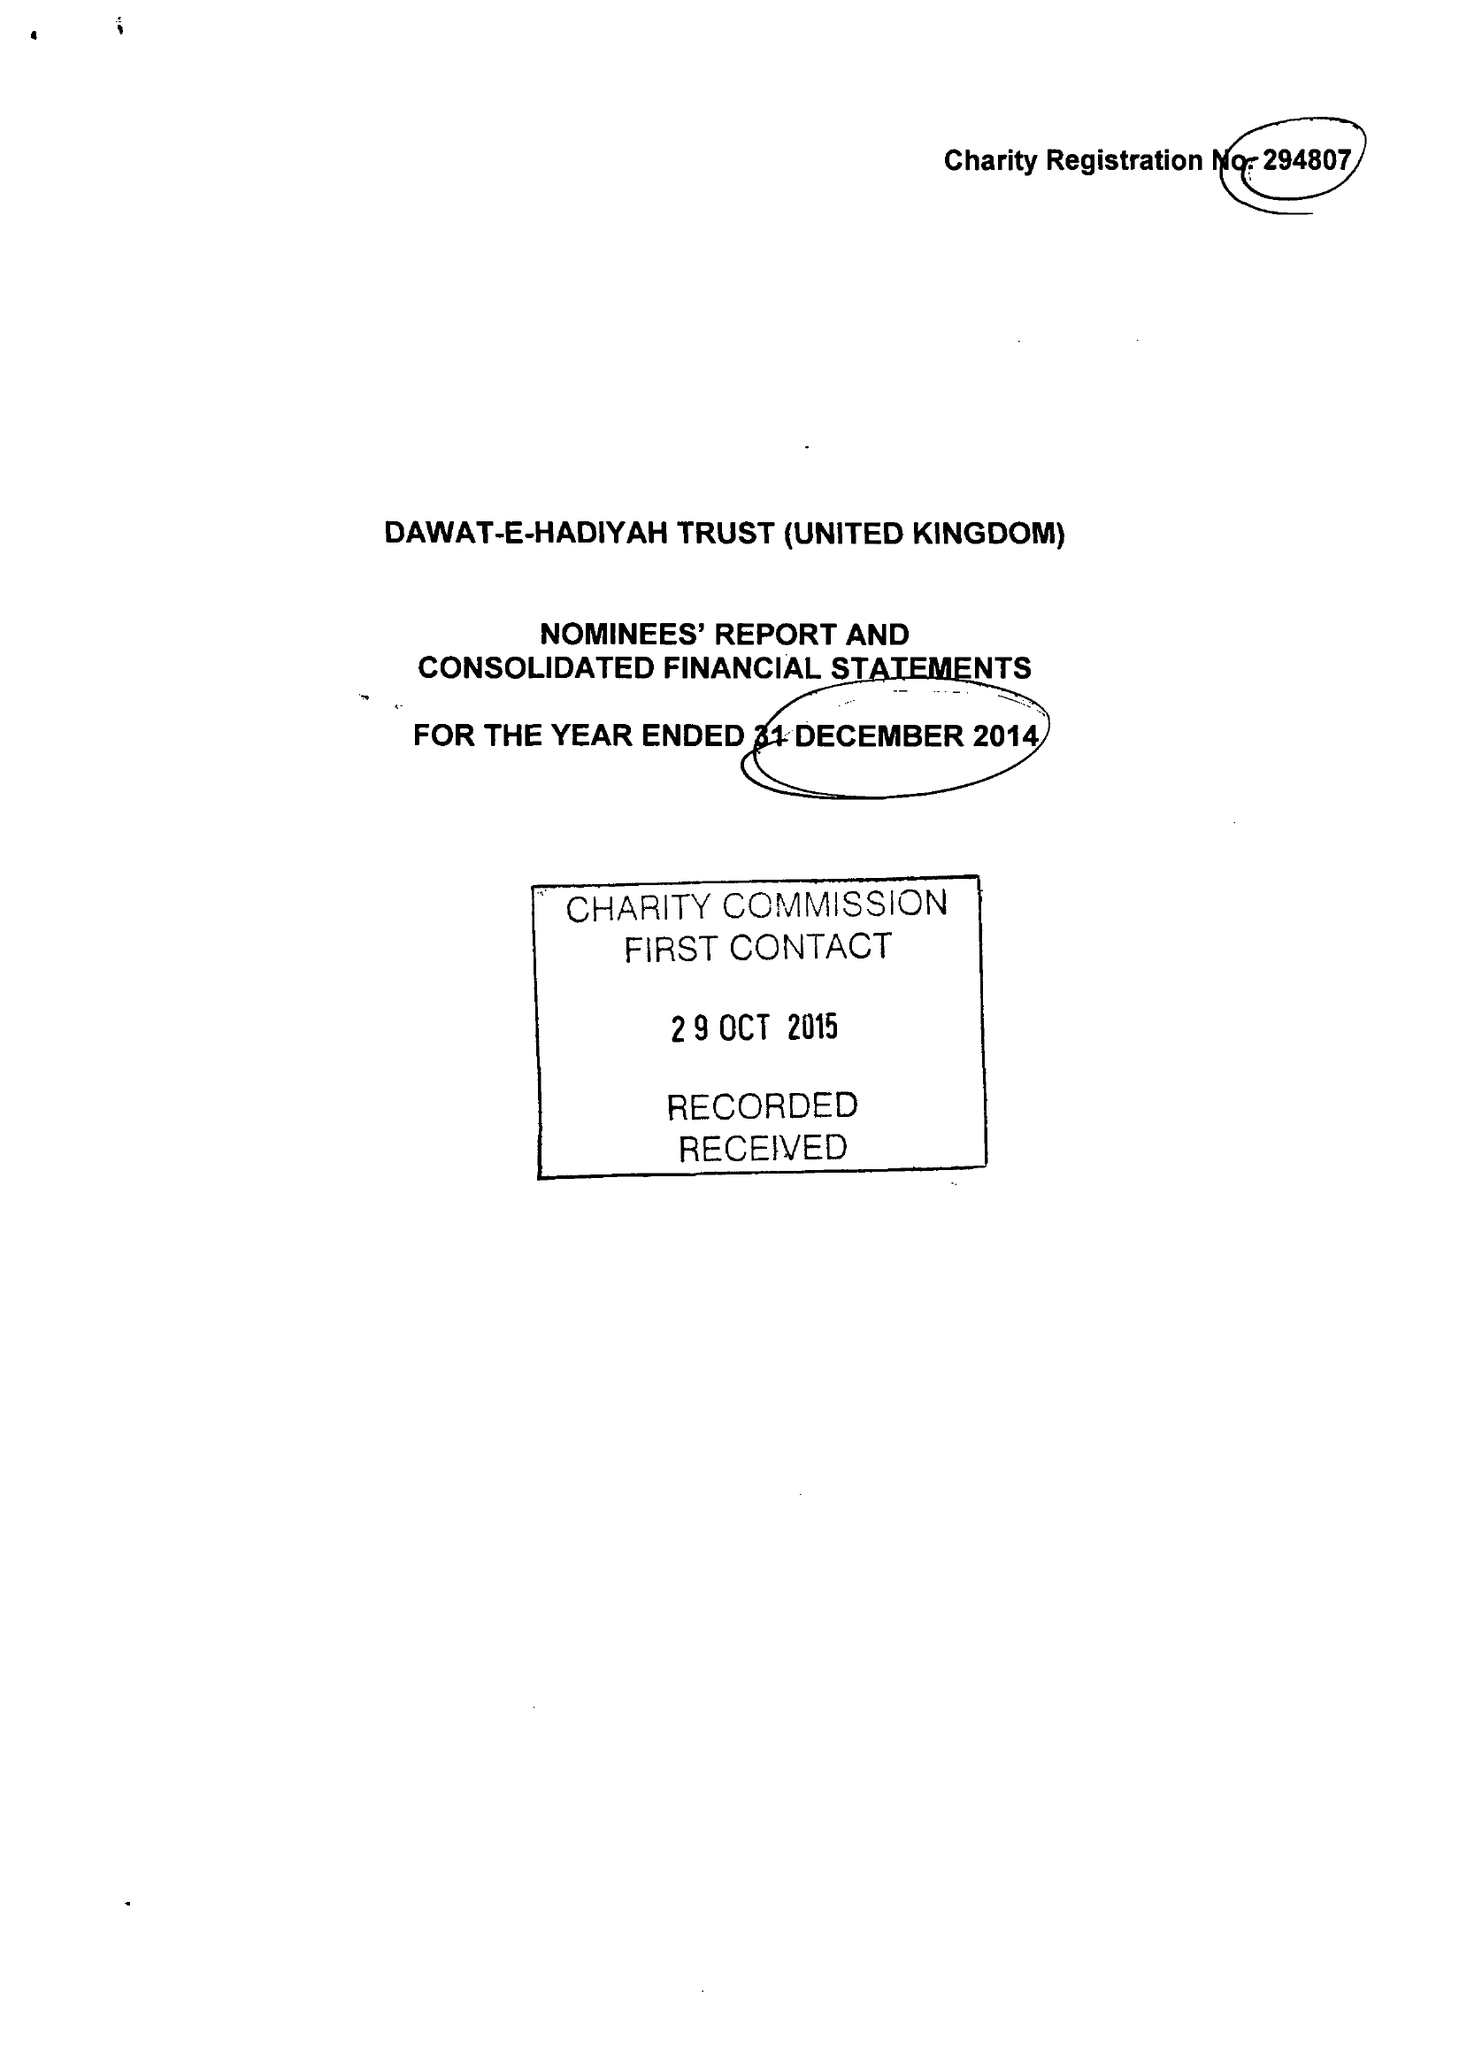What is the value for the income_annually_in_british_pounds?
Answer the question using a single word or phrase. 6091235.00 